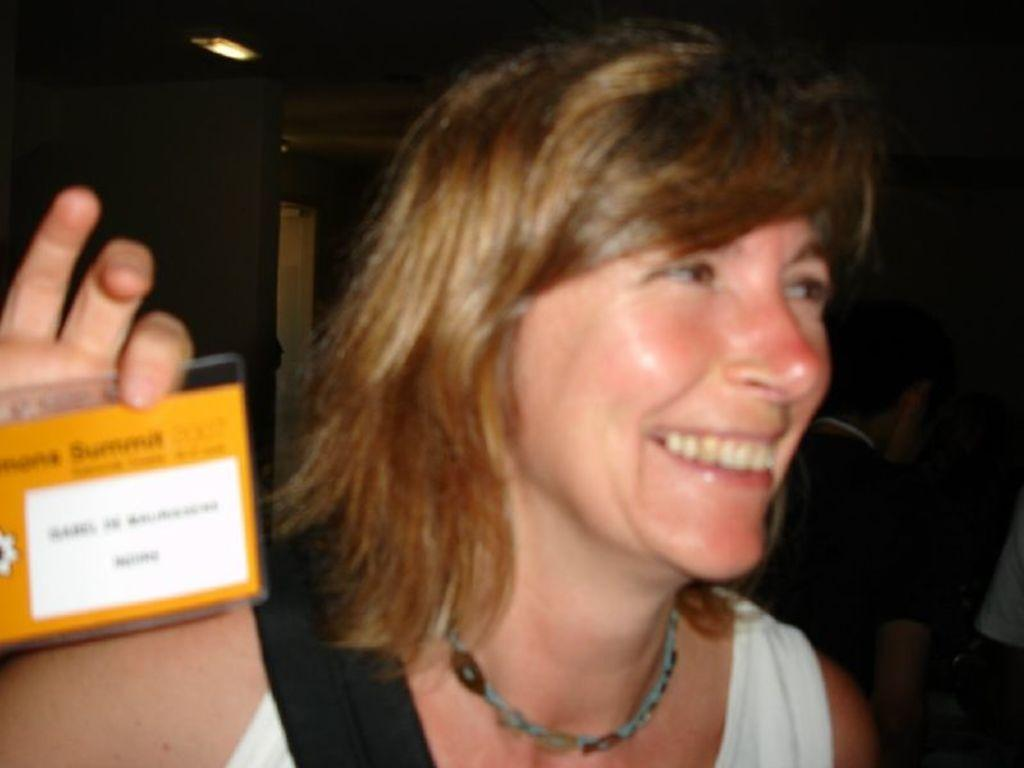What is the woman in the image holding? The woman is holding an ID card. What is the woman's facial expression in the image? The woman is smiling. What type of distribution is the woman involved in within the image? There is no indication of any distribution activity in the image; the woman is simply holding an ID card and smiling. 